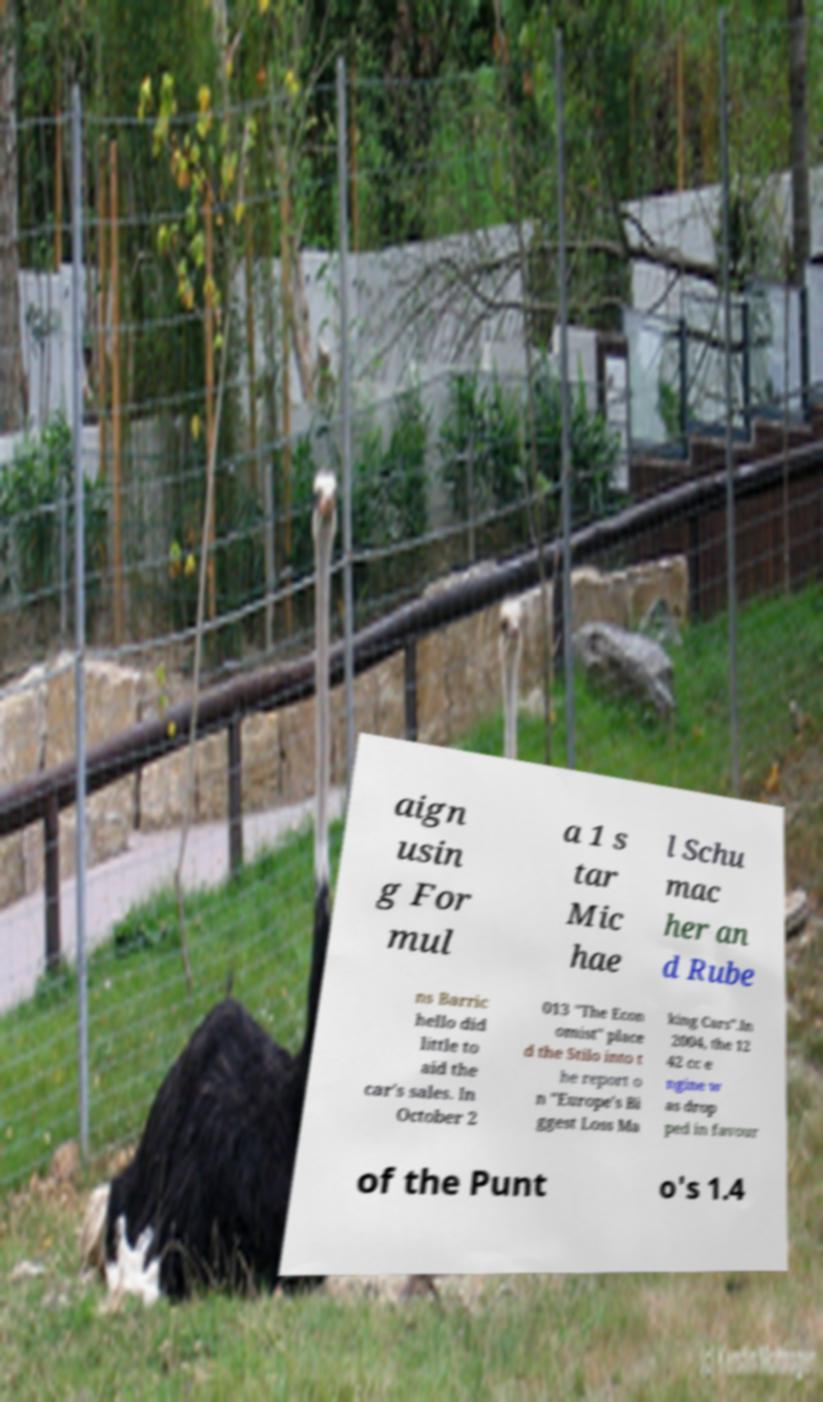Please read and relay the text visible in this image. What does it say? aign usin g For mul a 1 s tar Mic hae l Schu mac her an d Rube ns Barric hello did little to aid the car's sales. In October 2 013 "The Econ omist" place d the Stilo into t he report o n "Europe's Bi ggest Loss Ma king Cars".In 2004, the 12 42 cc e ngine w as drop ped in favour of the Punt o's 1.4 